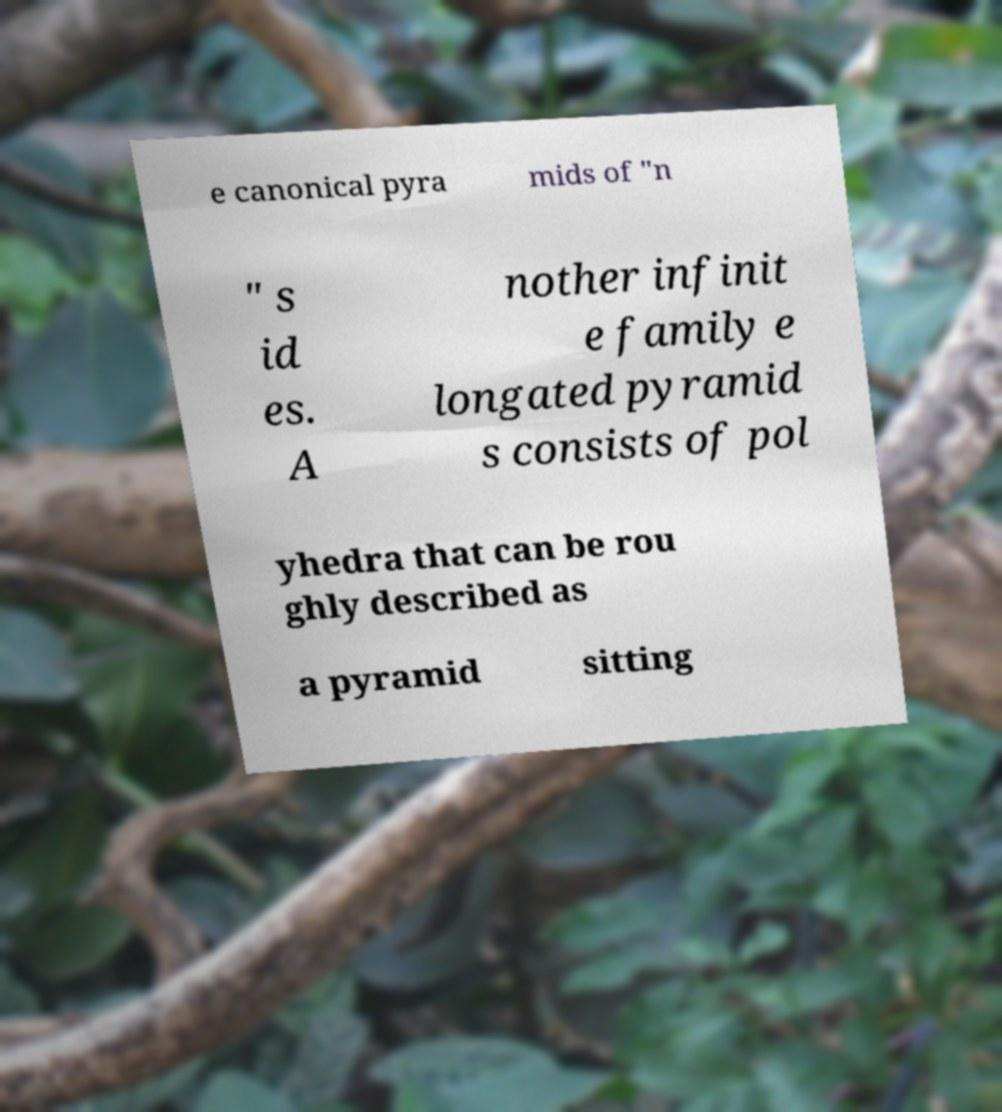Can you read and provide the text displayed in the image?This photo seems to have some interesting text. Can you extract and type it out for me? e canonical pyra mids of "n " s id es. A nother infinit e family e longated pyramid s consists of pol yhedra that can be rou ghly described as a pyramid sitting 